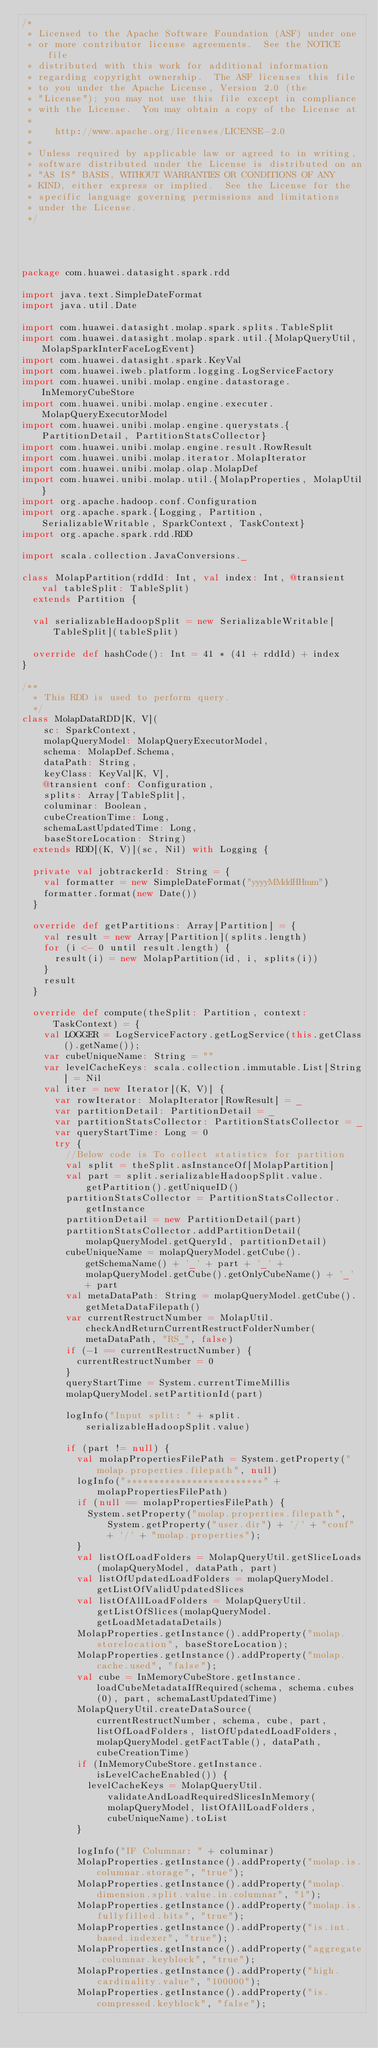Convert code to text. <code><loc_0><loc_0><loc_500><loc_500><_Scala_>/*
 * Licensed to the Apache Software Foundation (ASF) under one
 * or more contributor license agreements.  See the NOTICE file
 * distributed with this work for additional information
 * regarding copyright ownership.  The ASF licenses this file
 * to you under the Apache License, Version 2.0 (the
 * "License"); you may not use this file except in compliance
 * with the License.  You may obtain a copy of the License at
 *
 *    http://www.apache.org/licenses/LICENSE-2.0
 *
 * Unless required by applicable law or agreed to in writing,
 * software distributed under the License is distributed on an
 * "AS IS" BASIS, WITHOUT WARRANTIES OR CONDITIONS OF ANY
 * KIND, either express or implied.  See the License for the
 * specific language governing permissions and limitations
 * under the License.
 */




package com.huawei.datasight.spark.rdd

import java.text.SimpleDateFormat
import java.util.Date

import com.huawei.datasight.molap.spark.splits.TableSplit
import com.huawei.datasight.molap.spark.util.{MolapQueryUtil, MolapSparkInterFaceLogEvent}
import com.huawei.datasight.spark.KeyVal
import com.huawei.iweb.platform.logging.LogServiceFactory
import com.huawei.unibi.molap.engine.datastorage.InMemoryCubeStore
import com.huawei.unibi.molap.engine.executer.MolapQueryExecutorModel
import com.huawei.unibi.molap.engine.querystats.{PartitionDetail, PartitionStatsCollector}
import com.huawei.unibi.molap.engine.result.RowResult
import com.huawei.unibi.molap.iterator.MolapIterator
import com.huawei.unibi.molap.olap.MolapDef
import com.huawei.unibi.molap.util.{MolapProperties, MolapUtil}
import org.apache.hadoop.conf.Configuration
import org.apache.spark.{Logging, Partition, SerializableWritable, SparkContext, TaskContext}
import org.apache.spark.rdd.RDD

import scala.collection.JavaConversions._

class MolapPartition(rddId: Int, val index: Int, @transient val tableSplit: TableSplit)
  extends Partition {

  val serializableHadoopSplit = new SerializableWritable[TableSplit](tableSplit)

  override def hashCode(): Int = 41 * (41 + rddId) + index
}

/**
  * This RDD is used to perform query.
  */
class MolapDataRDD[K, V](
    sc: SparkContext,
    molapQueryModel: MolapQueryExecutorModel,
    schema: MolapDef.Schema,
    dataPath: String,
    keyClass: KeyVal[K, V],
    @transient conf: Configuration,
    splits: Array[TableSplit],
    columinar: Boolean,
    cubeCreationTime: Long,
    schemaLastUpdatedTime: Long,
    baseStoreLocation: String)
  extends RDD[(K, V)](sc, Nil) with Logging {

  private val jobtrackerId: String = {
    val formatter = new SimpleDateFormat("yyyyMMddHHmm")
    formatter.format(new Date())
  }

  override def getPartitions: Array[Partition] = {
    val result = new Array[Partition](splits.length)
    for (i <- 0 until result.length) {
      result(i) = new MolapPartition(id, i, splits(i))
    }
    result
  }

  override def compute(theSplit: Partition, context: TaskContext) = {
    val LOGGER = LogServiceFactory.getLogService(this.getClass().getName());
    var cubeUniqueName: String = ""
    var levelCacheKeys: scala.collection.immutable.List[String] = Nil
    val iter = new Iterator[(K, V)] {
      var rowIterator: MolapIterator[RowResult] = _
      var partitionDetail: PartitionDetail = _
      var partitionStatsCollector: PartitionStatsCollector = _
      var queryStartTime: Long = 0
      try {
        //Below code is To collect statistics for partition
        val split = theSplit.asInstanceOf[MolapPartition]
        val part = split.serializableHadoopSplit.value.getPartition().getUniqueID()
        partitionStatsCollector = PartitionStatsCollector.getInstance
        partitionDetail = new PartitionDetail(part)
        partitionStatsCollector.addPartitionDetail(molapQueryModel.getQueryId, partitionDetail)
        cubeUniqueName = molapQueryModel.getCube().getSchemaName() + '_' + part + '_' + molapQueryModel.getCube().getOnlyCubeName() + '_' + part
        val metaDataPath: String = molapQueryModel.getCube().getMetaDataFilepath()
        var currentRestructNumber = MolapUtil.checkAndReturnCurrentRestructFolderNumber(metaDataPath, "RS_", false)
        if (-1 == currentRestructNumber) {
          currentRestructNumber = 0
        }
        queryStartTime = System.currentTimeMillis
        molapQueryModel.setPartitionId(part)

        logInfo("Input split: " + split.serializableHadoopSplit.value)

        if (part != null) {
          val molapPropertiesFilePath = System.getProperty("molap.properties.filepath", null)
          logInfo("*************************" + molapPropertiesFilePath)
          if (null == molapPropertiesFilePath) {
            System.setProperty("molap.properties.filepath", System.getProperty("user.dir") + '/' + "conf" + '/' + "molap.properties");
          }
          val listOfLoadFolders = MolapQueryUtil.getSliceLoads(molapQueryModel, dataPath, part)
          val listOfUpdatedLoadFolders = molapQueryModel.getListOfValidUpdatedSlices
          val listOfAllLoadFolders = MolapQueryUtil.getListOfSlices(molapQueryModel.getLoadMetadataDetails)
          MolapProperties.getInstance().addProperty("molap.storelocation", baseStoreLocation);
          MolapProperties.getInstance().addProperty("molap.cache.used", "false");
          val cube = InMemoryCubeStore.getInstance.loadCubeMetadataIfRequired(schema, schema.cubes(0), part, schemaLastUpdatedTime)
          MolapQueryUtil.createDataSource(currentRestructNumber, schema, cube, part, listOfLoadFolders, listOfUpdatedLoadFolders, molapQueryModel.getFactTable(), dataPath, cubeCreationTime)
          if (InMemoryCubeStore.getInstance.isLevelCacheEnabled()) {
            levelCacheKeys = MolapQueryUtil.validateAndLoadRequiredSlicesInMemory(molapQueryModel, listOfAllLoadFolders, cubeUniqueName).toList
          }

          logInfo("IF Columnar: " + columinar)
          MolapProperties.getInstance().addProperty("molap.is.columnar.storage", "true");
          MolapProperties.getInstance().addProperty("molap.dimension.split.value.in.columnar", "1");
          MolapProperties.getInstance().addProperty("molap.is.fullyfilled.bits", "true");
          MolapProperties.getInstance().addProperty("is.int.based.indexer", "true");
          MolapProperties.getInstance().addProperty("aggregate.columnar.keyblock", "true");
          MolapProperties.getInstance().addProperty("high.cardinality.value", "100000");
          MolapProperties.getInstance().addProperty("is.compressed.keyblock", "false");</code> 